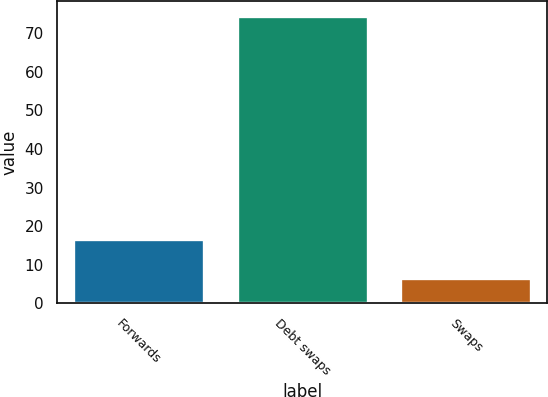Convert chart. <chart><loc_0><loc_0><loc_500><loc_500><bar_chart><fcel>Forwards<fcel>Debt swaps<fcel>Swaps<nl><fcel>16.6<fcel>74.5<fcel>6.5<nl></chart> 